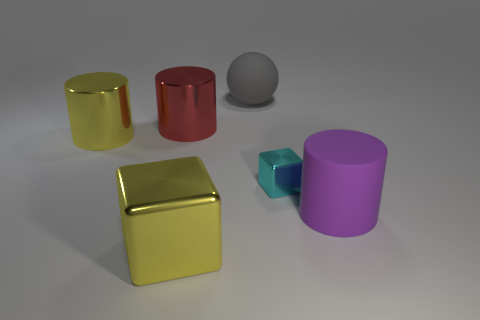Add 2 small metal spheres. How many objects exist? 8 Subtract all spheres. How many objects are left? 5 Subtract all large cylinders. Subtract all green rubber balls. How many objects are left? 3 Add 5 large cylinders. How many large cylinders are left? 8 Add 2 tiny cyan blocks. How many tiny cyan blocks exist? 3 Subtract 1 yellow blocks. How many objects are left? 5 